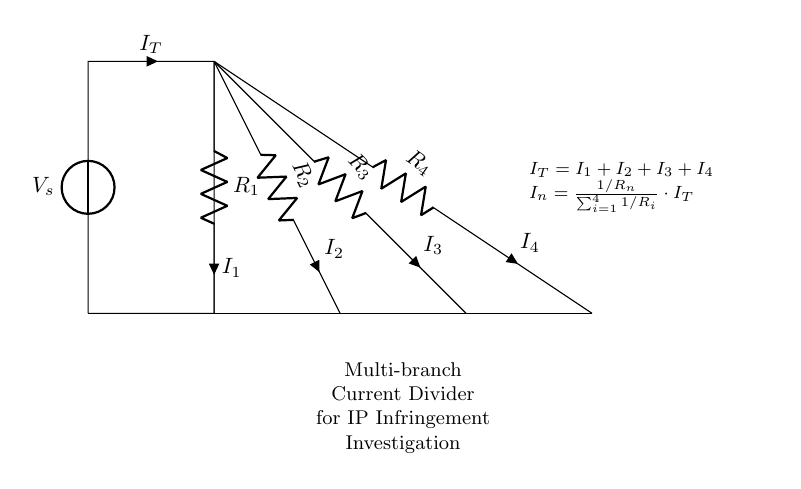What is the total current in the circuit? The total current, denoted as I_T, is the sum of the individual branch currents (I_1, I_2, I_3, and I_4). The equation indicates that I_T equals the sum of all currents through the resistors.
Answer: I_T What are the values of the resistors? The resistors are labeled as R_1, R_2, R_3, and R_4. The diagram does not provide specific numerical values, but they represent the components through which the current divides.
Answer: R_1, R_2, R_3, R_4 How many branches are in this circuit? The circuit contains four branches, each with its own resistor. The diagram clearly shows four separate paths for current to flow, indicating a multi-branch configuration.
Answer: Four What is the formula for calculating the current through a specific resistor? The formula given in the diagram shows that the current through any resistor (I_n) is calculated using the resistance value of that resistor compared to the total resistance of all resistors, multiplied by the total current (I_T).
Answer: I_n = (1/R_n) / Σ(1/R_i) * I_T If R_1 increases, what happens to I_1? According to the current divider principle, if R_1 (increases) increases, the fraction of total current I_T that passes through that branch (I_1) will decrease, as a higher resistance results in less current flow through that path.
Answer: Decreases What does the acronym IP refer to in this context? The acronym "IP" stands for Intellectual Property, which is pertinent in the context of investigating any potential infringements related to the electronic devices represented in the circuit.
Answer: Intellectual Property 